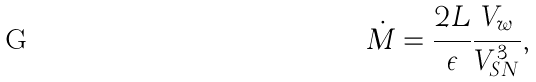<formula> <loc_0><loc_0><loc_500><loc_500>\dot { M } = \frac { 2 L } { \epsilon } \frac { V _ { w } } { V _ { S N } ^ { 3 } } ,</formula> 